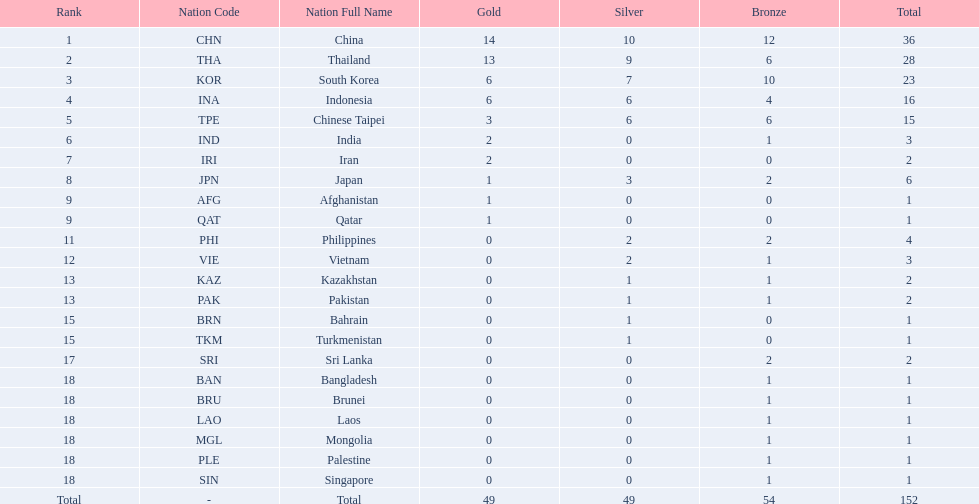Could you parse the entire table as a dict? {'header': ['Rank', 'Nation Code', 'Nation Full Name', 'Gold', 'Silver', 'Bronze', 'Total'], 'rows': [['1', 'CHN', 'China', '14', '10', '12', '36'], ['2', 'THA', 'Thailand', '13', '9', '6', '28'], ['3', 'KOR', 'South Korea', '6', '7', '10', '23'], ['4', 'INA', 'Indonesia', '6', '6', '4', '16'], ['5', 'TPE', 'Chinese Taipei', '3', '6', '6', '15'], ['6', 'IND', 'India', '2', '0', '1', '3'], ['7', 'IRI', 'Iran', '2', '0', '0', '2'], ['8', 'JPN', 'Japan', '1', '3', '2', '6'], ['9', 'AFG', 'Afghanistan', '1', '0', '0', '1'], ['9', 'QAT', 'Qatar', '1', '0', '0', '1'], ['11', 'PHI', 'Philippines', '0', '2', '2', '4'], ['12', 'VIE', 'Vietnam', '0', '2', '1', '3'], ['13', 'KAZ', 'Kazakhstan', '0', '1', '1', '2'], ['13', 'PAK', 'Pakistan', '0', '1', '1', '2'], ['15', 'BRN', 'Bahrain', '0', '1', '0', '1'], ['15', 'TKM', 'Turkmenistan', '0', '1', '0', '1'], ['17', 'SRI', 'Sri Lanka', '0', '0', '2', '2'], ['18', 'BAN', 'Bangladesh', '0', '0', '1', '1'], ['18', 'BRU', 'Brunei', '0', '0', '1', '1'], ['18', 'LAO', 'Laos', '0', '0', '1', '1'], ['18', 'MGL', 'Mongolia', '0', '0', '1', '1'], ['18', 'PLE', 'Palestine', '0', '0', '1', '1'], ['18', 'SIN', 'Singapore', '0', '0', '1', '1'], ['Total', '-', 'Total', '49', '49', '54', '152']]} How many total gold medal have been given? 49. 